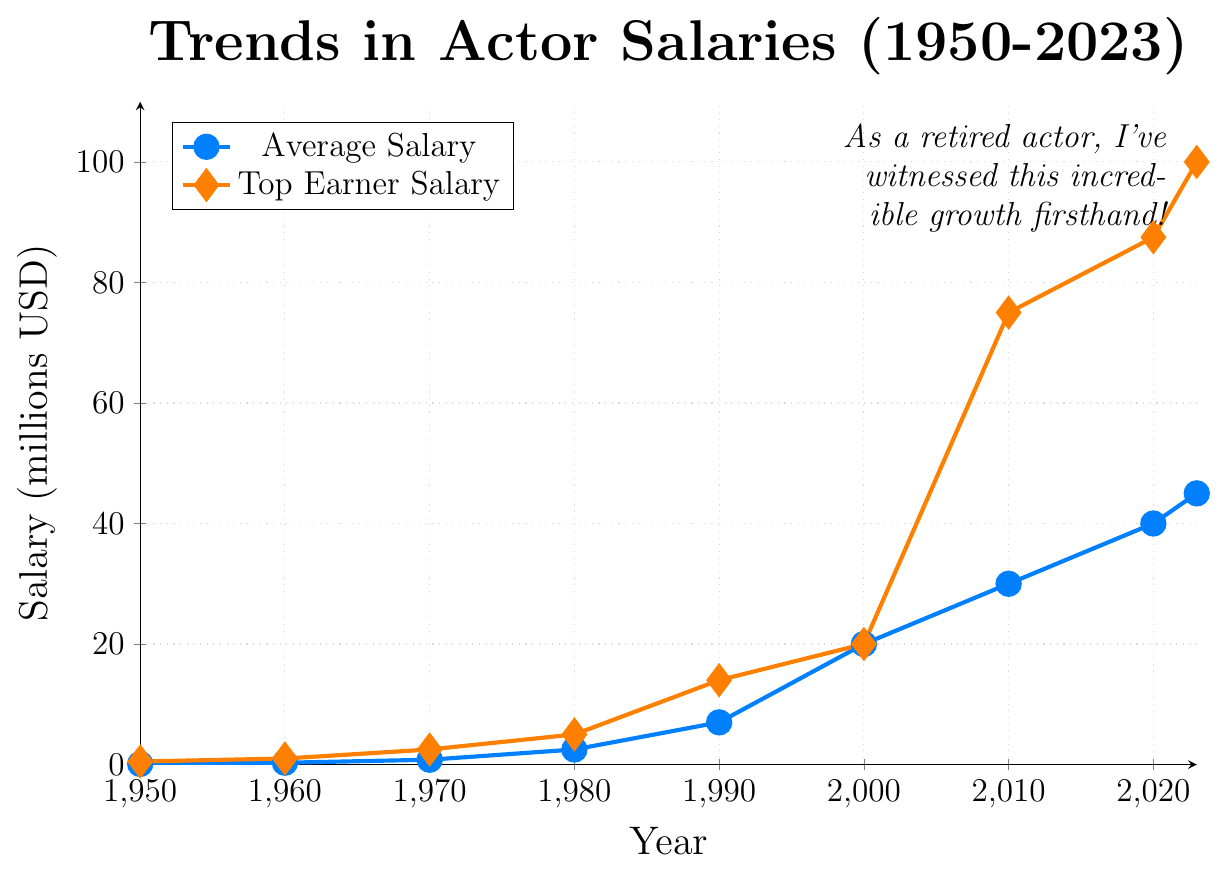What's the overall trend of the average salary from 1950 to the present? The trend shows a consistent increase in the average salary for leading roles from 1950 to the present, rising from 0.1 million USD in 1950 to 45.0 million USD in 2023.
Answer: Consistent increase Who was the top earner in 1970 and what was their salary? According to the figure, Paul Newman was the top earner in 1970 with a salary of 2.5 million USD.
Answer: Paul Newman, 2.5 million USD What was the difference in the top earner's salary between 1980 and 2023? The top earner's salary in 1980 was 5.0 million USD, while in 2023 it was 100.0 million USD. The difference is 100.0 - 5.0 = 95.0 million USD.
Answer: 95.0 million USD How does the increase in the average salary from 2000 to 2010 compare to the increase from 2010 to 2020? From 2000 to 2010, the average salary increased from 20.0 million USD to 30.0 million USD, which is an increase of 10.0 million USD. From 2010 to 2020, it increased from 30.0 million USD to 40.0 million USD, which is also an increase of 10.0 million USD. Both periods saw an equal increase of 10.0 million USD.
Answer: Equal increase of 10.0 million USD Which color line represents the top earner salary trend? The top earner salary trend is represented by the orange line, as indicated in the legend.
Answer: Orange line Which year showed the most significant jump in the top earner's salary, and by how much? The most significant jump in the top earner's salary occurred between 2000 and 2010. The top earner's salary jumped from 20.0 million USD to 75.0 million USD, which is an increase of 55.0 million USD.
Answer: 2000 to 2010, increase of 55.0 million USD What is the ratio of the top earner's salary to the average salary in 2023? In 2023, the top earner's salary is 100.0 million USD and the average salary is 45.0 million USD. The ratio is 100.0 / 45.0, which simplifies to approximately 2.22.
Answer: Approximately 2.22 Between which two consecutive decades did the average salary increase the most? To determine the decade with the most significant increase:
- 1950-1960: 0.2 million USD
- 1960-1970: 0.5 million USD
- 1970-1980: 1.7 million USD
- 1980-1990: 4.5 million USD
- 1990-2000: 13.0 million USD
- 2000-2010: 10.0 million USD
- 2010-2020: 10.0 million USD
The most significant increase happened between 1990 and 2000, with an increase of 13.0 million USD.
Answer: 1990 to 2000 How many times did the top earner's salary double or more in subsequent decades? We need to track if the top earner’s salary doubled or more in each subsequent decade:
- 1950 (0.5) to 1960 (1.0): Doubled
- 1960 (1.0) to 1970 (2.5): More than doubled
- 1970 (2.5) to 1980 (5.0): Doubled
- 1980 (5.0) to 1990 (14.0): More than doubled
- 1990 (14.0) to 2000 (20.0): Less than doubled
- 2000 (20.0) to 2010 (75.0): More than tripled
- 2010 (75.0) to 2020 (87.5): Less than doubled
In total, the top earner’s salary doubled or more 4 times.
Answer: 4 times Which year saw the top earner with a salary equal to the average salary? The year 2000 saw the top earner, who was Julia Roberts, with a salary equal to the average salary of 20.0 million USD.
Answer: 2000 